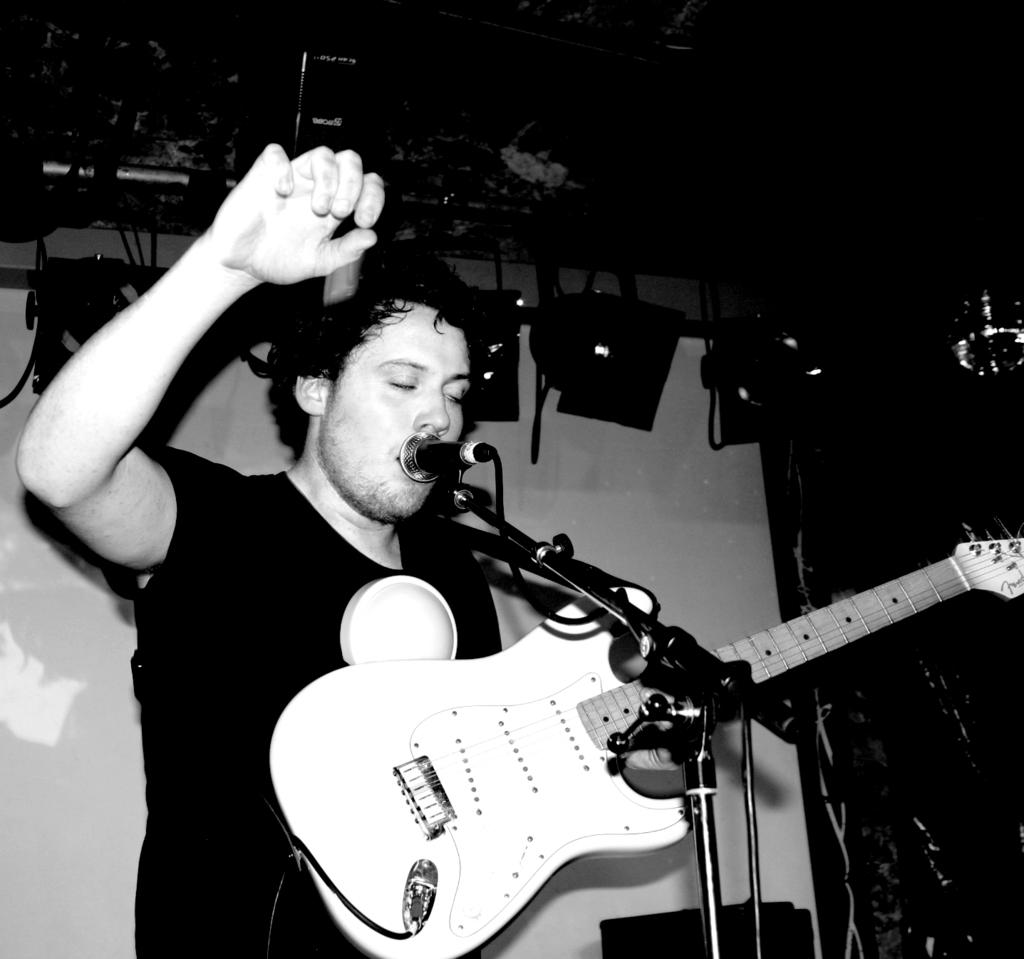What is the man in the image doing? The man is holding a guitar and singing. What instrument is the man holding in the image? The man is holding a guitar in the image. What can be seen in the background of the image? There are objects in the background of the image. Is the man driving a car in the image? No, the man is not driving a car in the image; he is holding a guitar and singing. How many cats are visible in the image? There are no cats present in the image. 